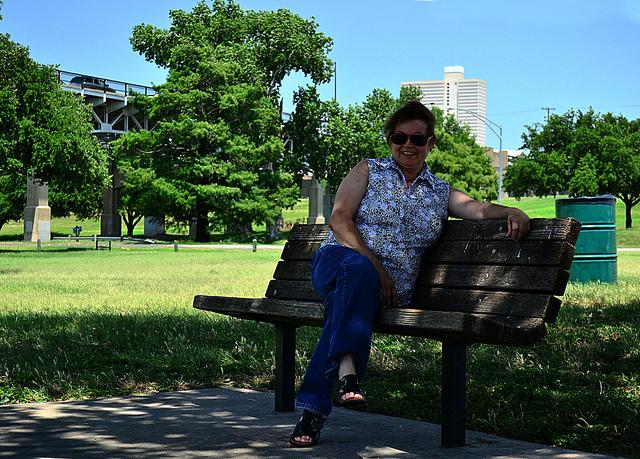What outdoor area is the woman sitting in?

Choices:
A) backyard
B) tunnel
C) garden
D) park park 